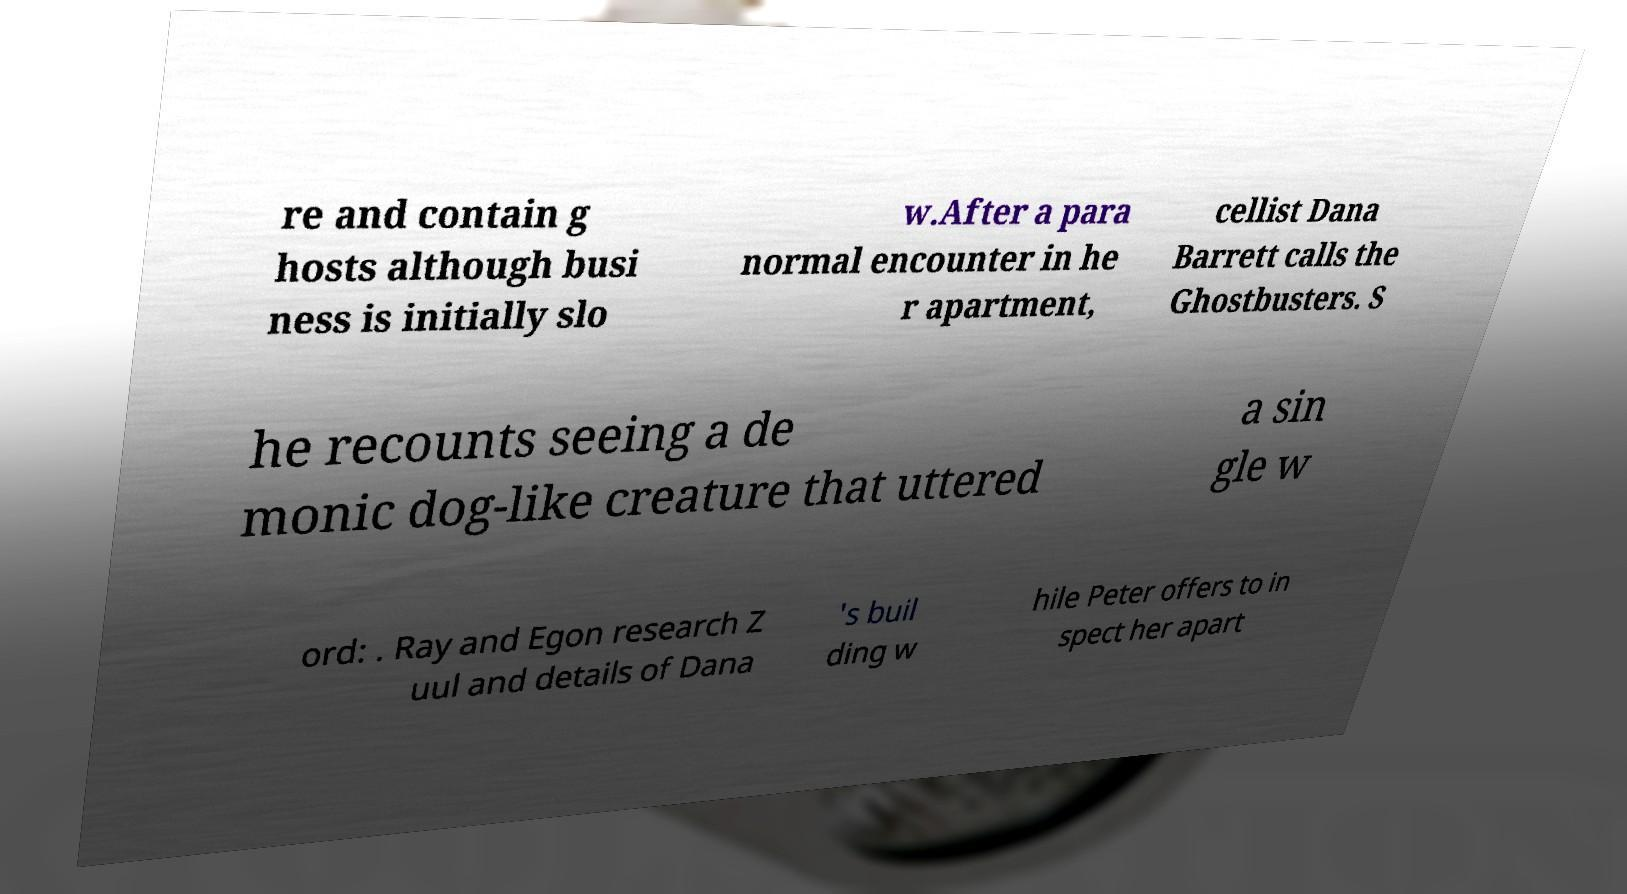Please identify and transcribe the text found in this image. re and contain g hosts although busi ness is initially slo w.After a para normal encounter in he r apartment, cellist Dana Barrett calls the Ghostbusters. S he recounts seeing a de monic dog-like creature that uttered a sin gle w ord: . Ray and Egon research Z uul and details of Dana 's buil ding w hile Peter offers to in spect her apart 